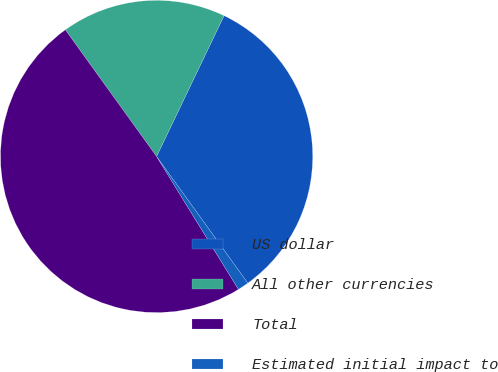Convert chart to OTSL. <chart><loc_0><loc_0><loc_500><loc_500><pie_chart><fcel>US dollar<fcel>All other currencies<fcel>Total<fcel>Estimated initial impact to<nl><fcel>32.95%<fcel>17.05%<fcel>48.85%<fcel>1.15%<nl></chart> 